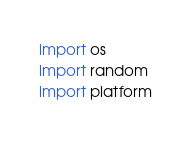<code> <loc_0><loc_0><loc_500><loc_500><_Python_>import os
import random
import platform
</code> 